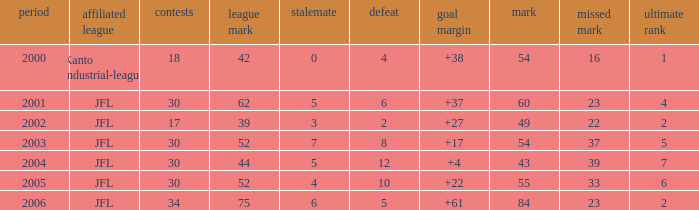Could you parse the entire table as a dict? {'header': ['period', 'affiliated league', 'contests', 'league mark', 'stalemate', 'defeat', 'goal margin', 'mark', 'missed mark', 'ultimate rank'], 'rows': [['2000', 'Kanto industrial-league', '18', '42', '0', '4', '+38', '54', '16', '1'], ['2001', 'JFL', '30', '62', '5', '6', '+37', '60', '23', '4'], ['2002', 'JFL', '17', '39', '3', '2', '+27', '49', '22', '2'], ['2003', 'JFL', '30', '52', '7', '8', '+17', '54', '37', '5'], ['2004', 'JFL', '30', '44', '5', '12', '+4', '43', '39', '7'], ['2005', 'JFL', '30', '52', '4', '10', '+22', '55', '33', '6'], ['2006', 'JFL', '34', '75', '6', '5', '+61', '84', '23', '2']]} Tell me the highest point with lost point being 33 and league point less than 52 None. 